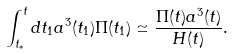<formula> <loc_0><loc_0><loc_500><loc_500>\int _ { t _ { * } } ^ { t } d t _ { 1 } a ^ { 3 } ( t _ { 1 } ) \Pi ( t _ { 1 } ) \simeq \frac { \Pi ( t ) a ^ { 3 } ( t ) } { H ( t ) } .</formula> 